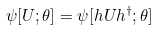Convert formula to latex. <formula><loc_0><loc_0><loc_500><loc_500>\psi [ U ; \theta ] = \psi [ h U h ^ { \dagger } ; \theta ]</formula> 